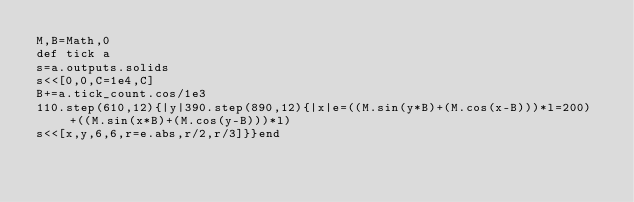Convert code to text. <code><loc_0><loc_0><loc_500><loc_500><_Ruby_>M,B=Math,0
def tick a
s=a.outputs.solids
s<<[0,0,C=1e4,C]
B+=a.tick_count.cos/1e3
110.step(610,12){|y|390.step(890,12){|x|e=((M.sin(y*B)+(M.cos(x-B)))*l=200)+((M.sin(x*B)+(M.cos(y-B)))*l)
s<<[x,y,6,6,r=e.abs,r/2,r/3]}}end</code> 